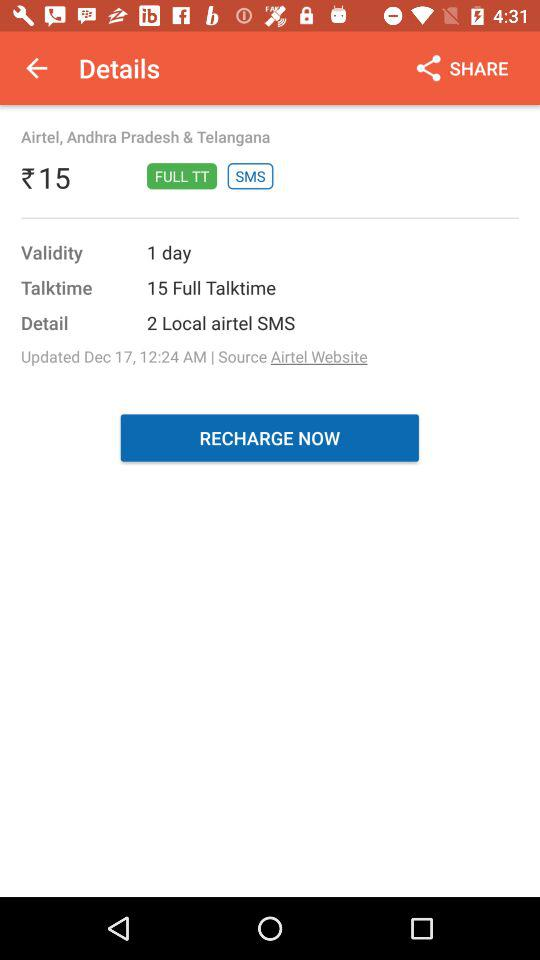What is the validity? The validity is 1 day. 